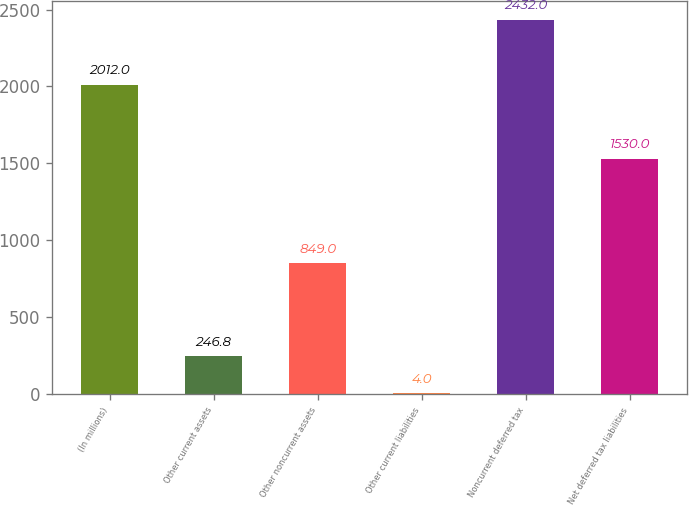<chart> <loc_0><loc_0><loc_500><loc_500><bar_chart><fcel>(In millions)<fcel>Other current assets<fcel>Other noncurrent assets<fcel>Other current liabilities<fcel>Noncurrent deferred tax<fcel>Net deferred tax liabilities<nl><fcel>2012<fcel>246.8<fcel>849<fcel>4<fcel>2432<fcel>1530<nl></chart> 